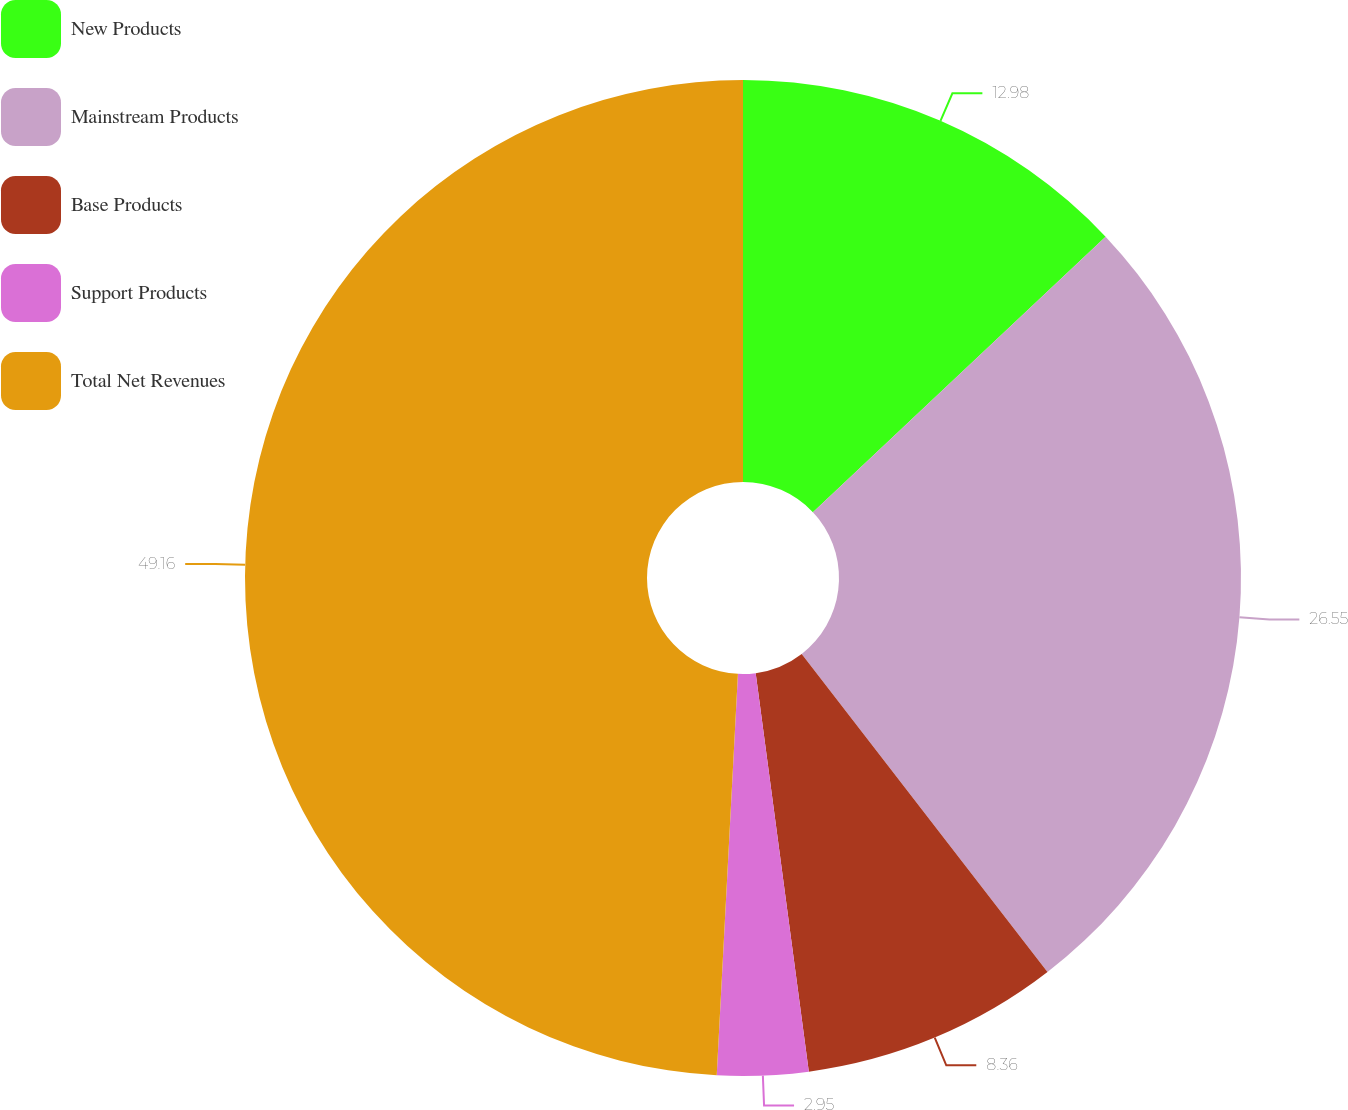<chart> <loc_0><loc_0><loc_500><loc_500><pie_chart><fcel>New Products<fcel>Mainstream Products<fcel>Base Products<fcel>Support Products<fcel>Total Net Revenues<nl><fcel>12.98%<fcel>26.55%<fcel>8.36%<fcel>2.95%<fcel>49.16%<nl></chart> 